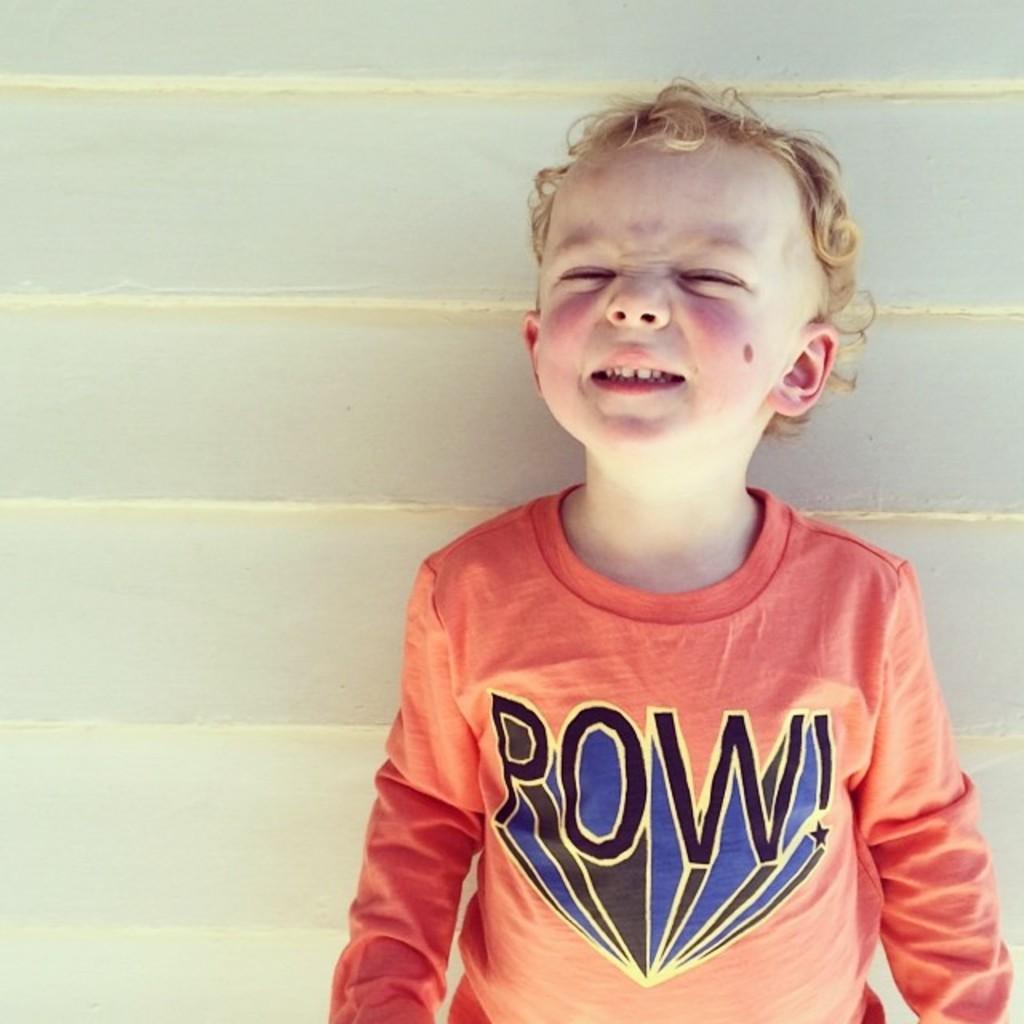What is the main subject of the image? There is a boy standing in the image. What is the boy wearing? The boy is wearing a T-shirt. What can be seen in the background of the image? There is a wall in the background of the image. What is the color of the wall? The wall is white in color. What type of offer can be seen on the shelf in the image? There is no shelf or offer present in the image; it features a boy standing in front of a white wall. 